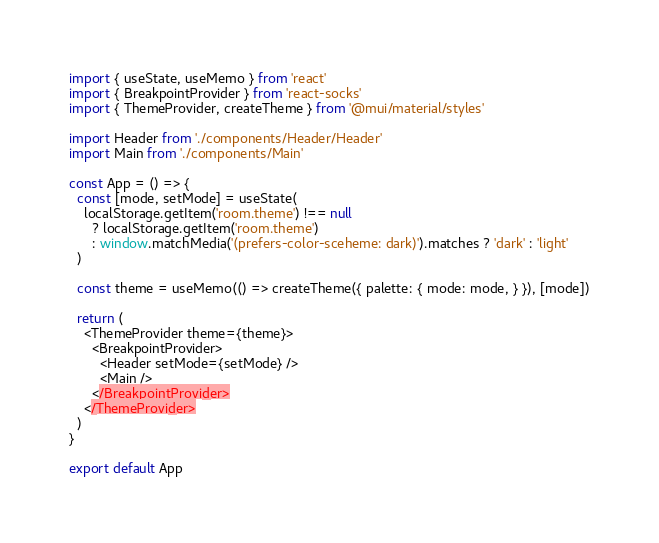Convert code to text. <code><loc_0><loc_0><loc_500><loc_500><_JavaScript_>import { useState, useMemo } from 'react'
import { BreakpointProvider } from 'react-socks'
import { ThemeProvider, createTheme } from '@mui/material/styles'

import Header from './components/Header/Header'
import Main from './components/Main'

const App = () => {
  const [mode, setMode] = useState(
    localStorage.getItem('room.theme') !== null
      ? localStorage.getItem('room.theme')
      : window.matchMedia('(prefers-color-sceheme: dark)').matches ? 'dark' : 'light'
  )

  const theme = useMemo(() => createTheme({ palette: { mode: mode, } }), [mode])

  return (
    <ThemeProvider theme={theme}>
      <BreakpointProvider>
        <Header setMode={setMode} />
        <Main />
      </BreakpointProvider>
    </ThemeProvider>
  )
}

export default App
</code> 